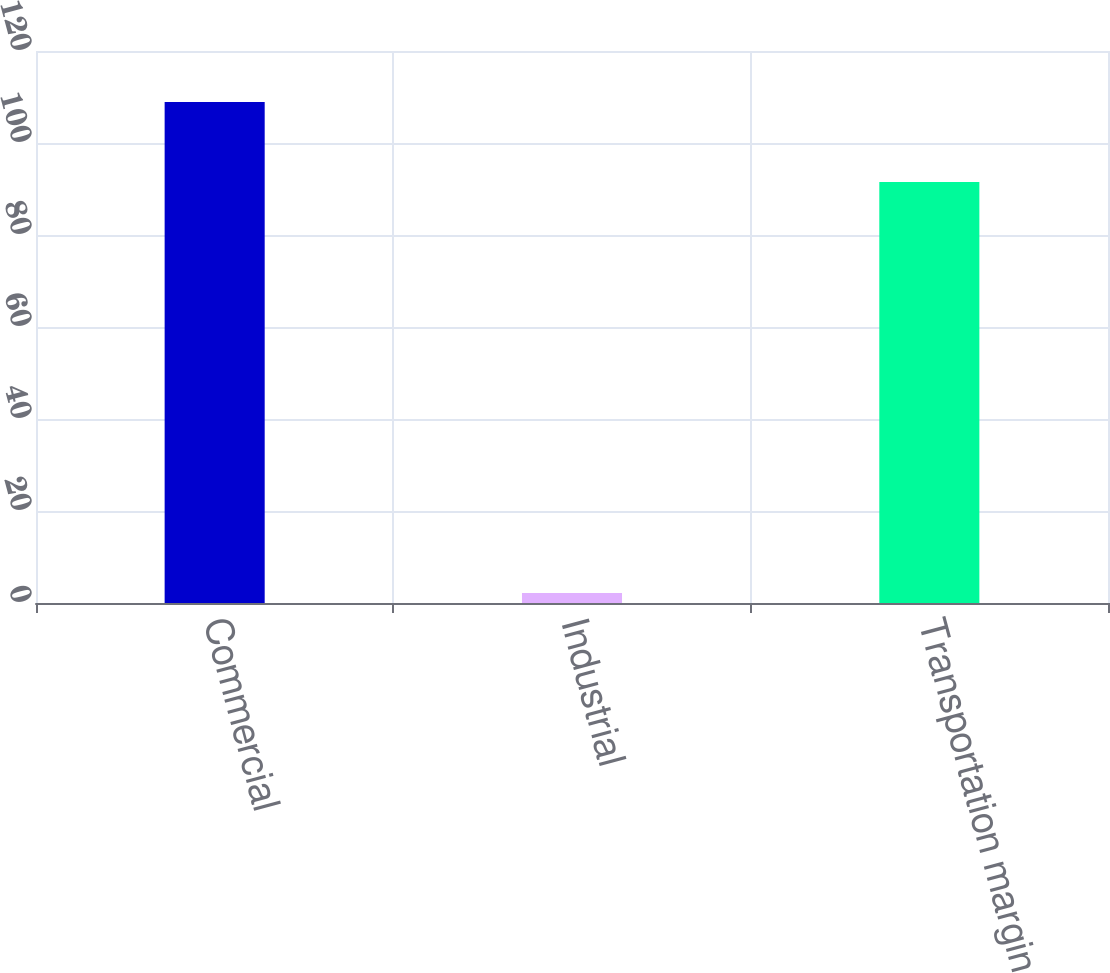<chart> <loc_0><loc_0><loc_500><loc_500><bar_chart><fcel>Commercial<fcel>Industrial<fcel>Transportation margin<nl><fcel>108.9<fcel>2.2<fcel>91.5<nl></chart> 